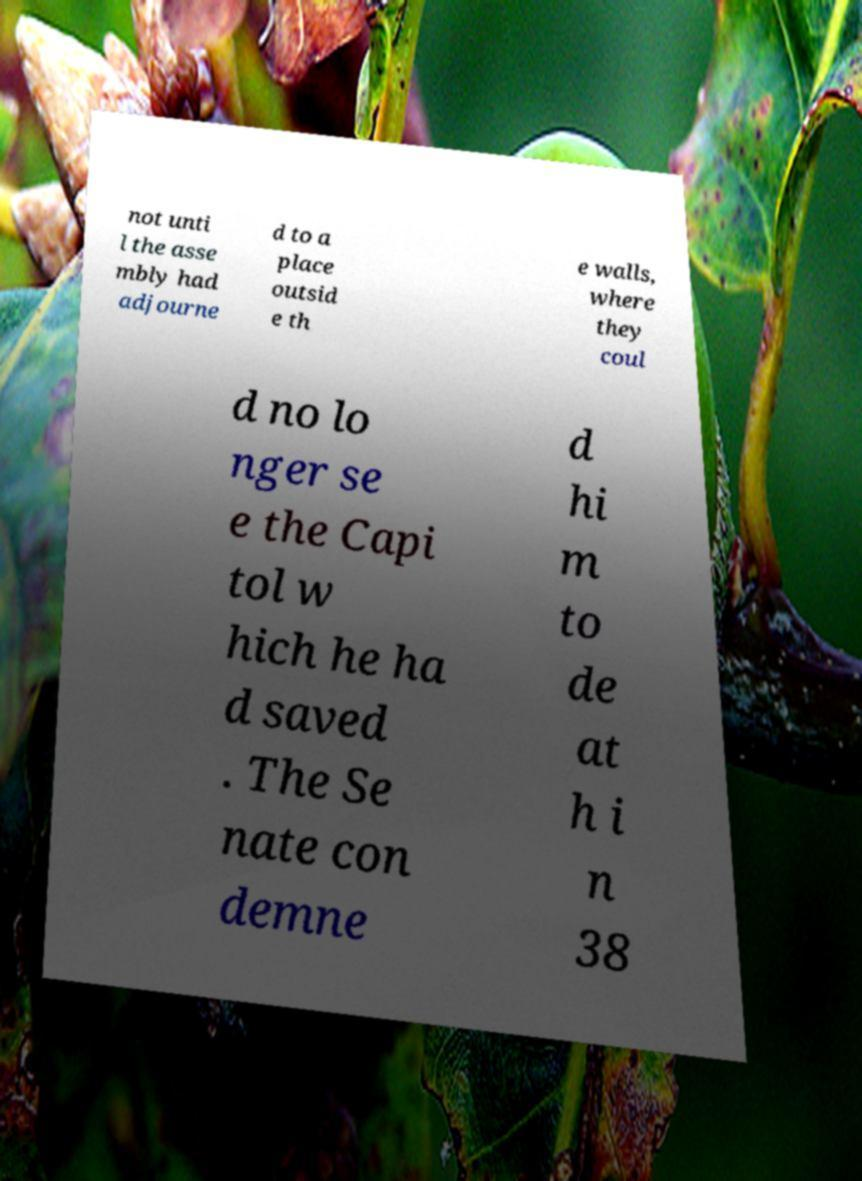Please identify and transcribe the text found in this image. not unti l the asse mbly had adjourne d to a place outsid e th e walls, where they coul d no lo nger se e the Capi tol w hich he ha d saved . The Se nate con demne d hi m to de at h i n 38 